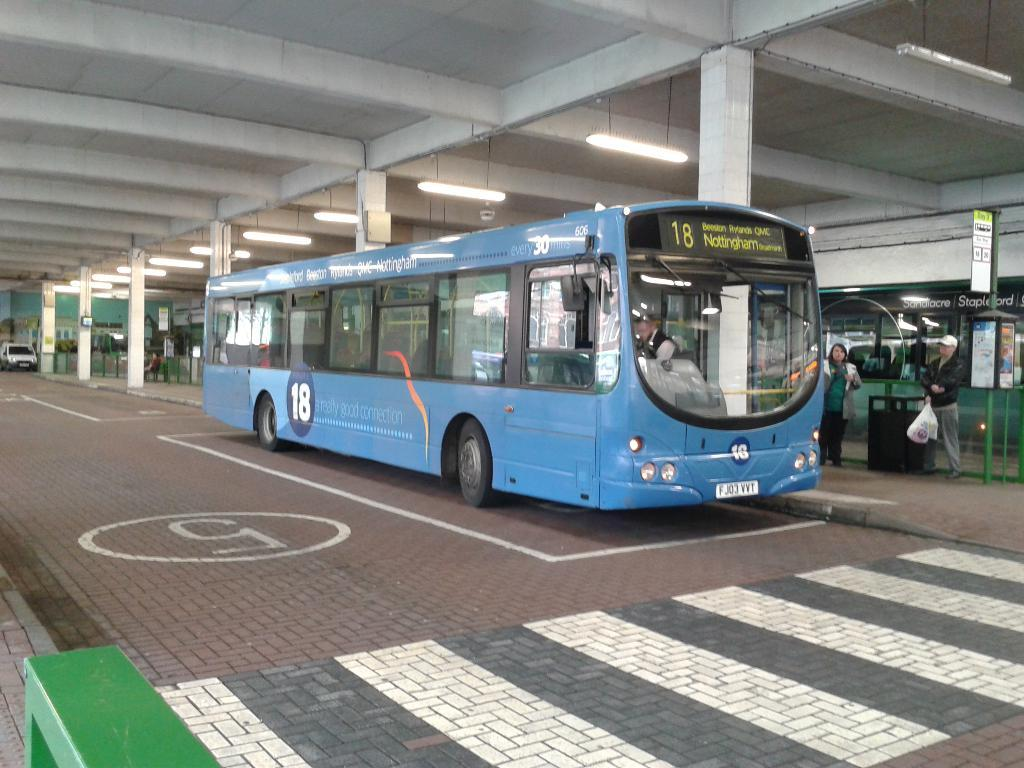<image>
Write a terse but informative summary of the picture. A blue single decker bus with the number 18 on the front. 